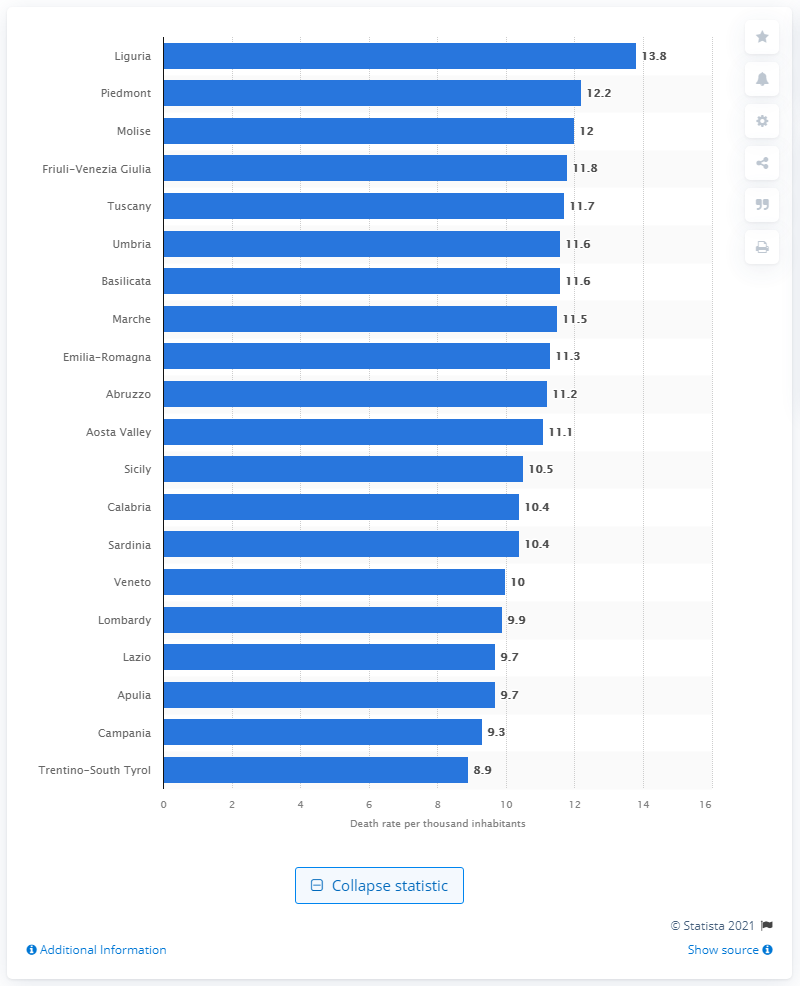List a handful of essential elements in this visual. Liguria had the highest death rate in Italy in 2019. Veneto, a region in Italy, had the least number of deaths in 2019, compared to other regions in the country. 